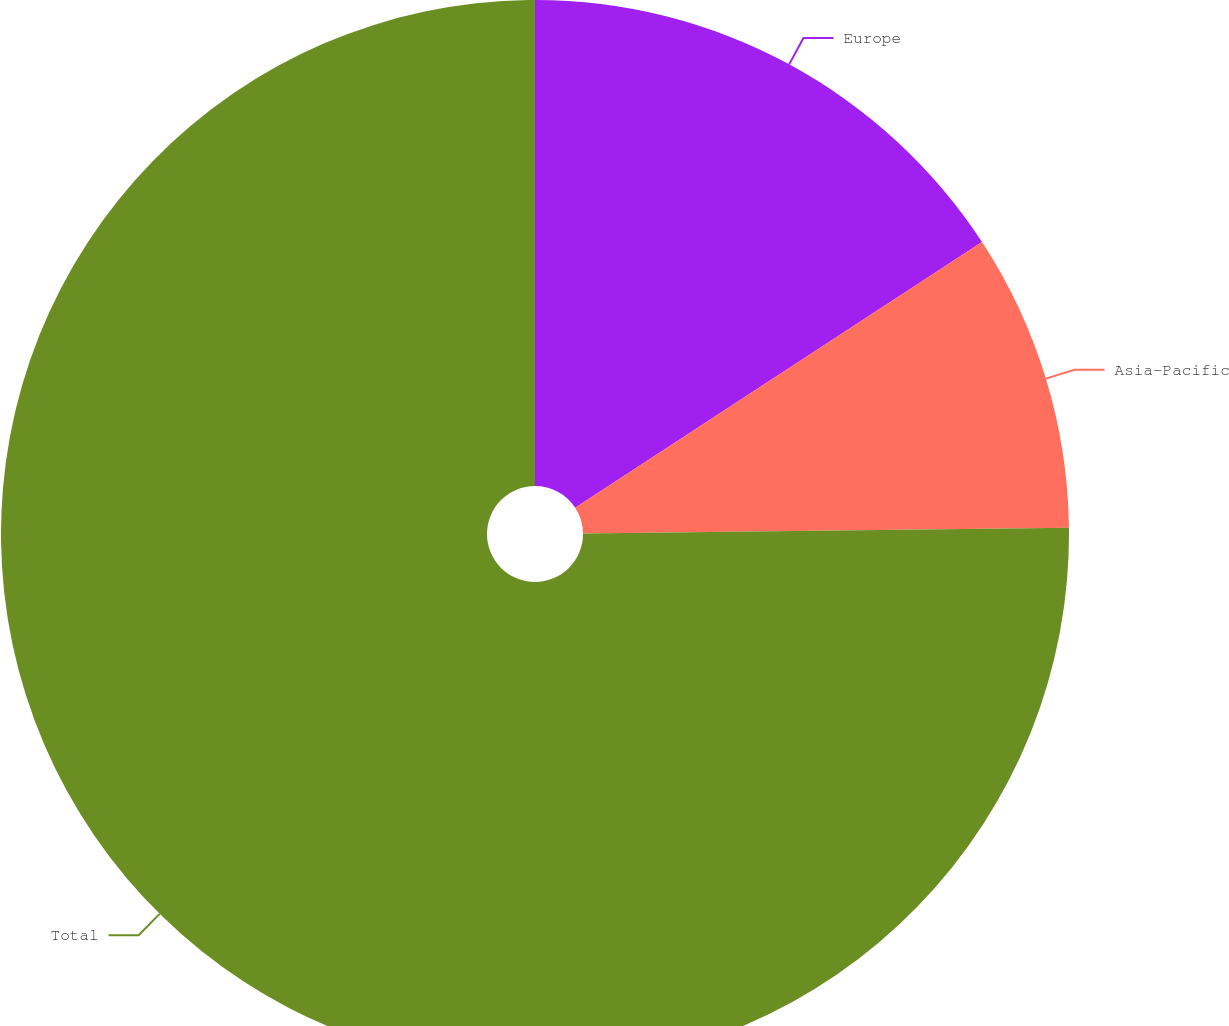Convert chart to OTSL. <chart><loc_0><loc_0><loc_500><loc_500><pie_chart><fcel>Europe<fcel>Asia-Pacific<fcel>Total<nl><fcel>15.79%<fcel>9.02%<fcel>75.19%<nl></chart> 